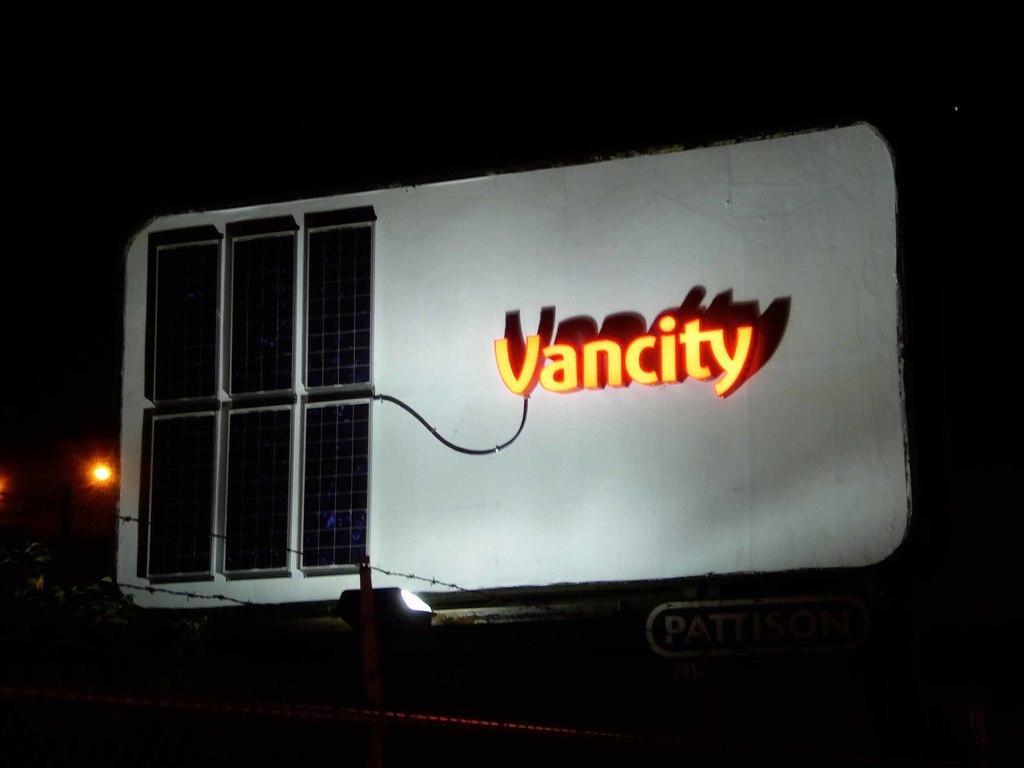What can be identified in the image based on the provided facts? There is a name and an orange color light visible in the image. Can you describe the orange color light in the image? The orange color light is a prominent feature in the image. Is there a robin hopping around in the image? There is no robin present in the image. Can you see any quicksand in the image? There is no quicksand present in the image. 